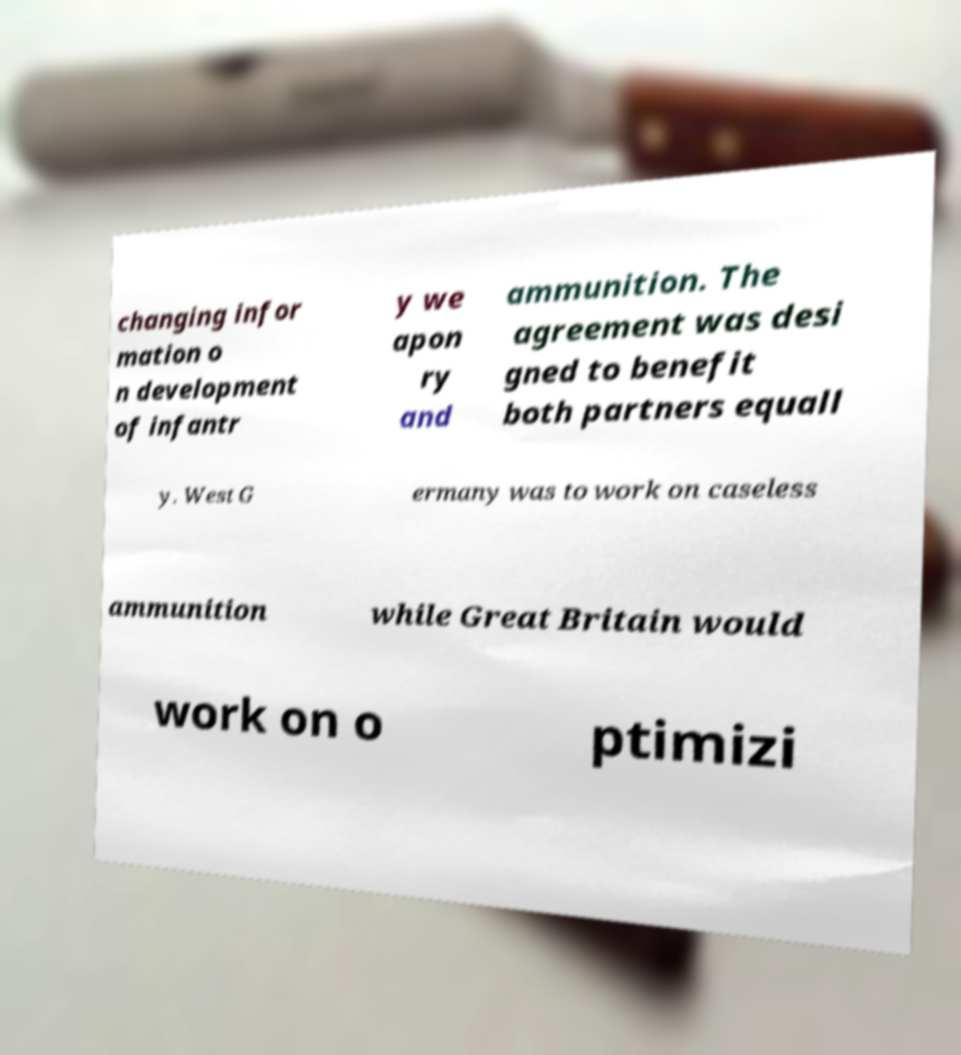Please identify and transcribe the text found in this image. changing infor mation o n development of infantr y we apon ry and ammunition. The agreement was desi gned to benefit both partners equall y. West G ermany was to work on caseless ammunition while Great Britain would work on o ptimizi 